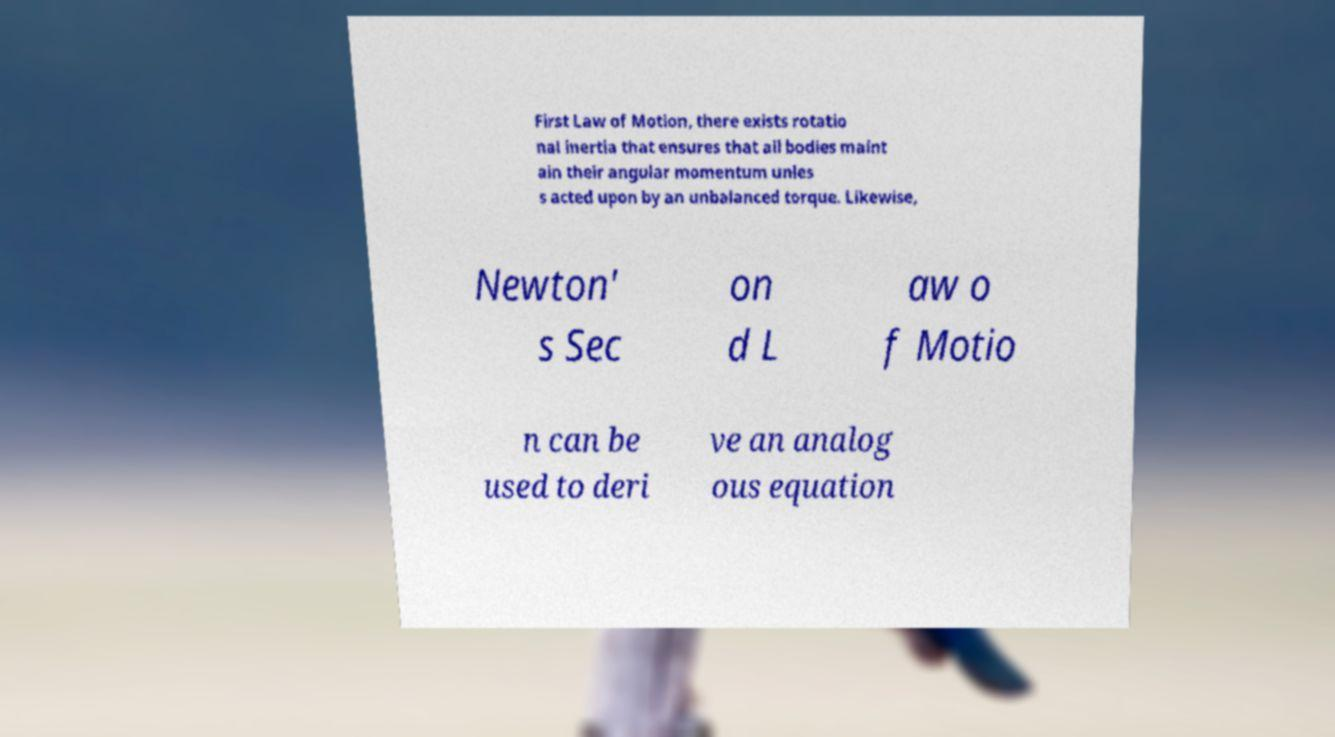For documentation purposes, I need the text within this image transcribed. Could you provide that? First Law of Motion, there exists rotatio nal inertia that ensures that all bodies maint ain their angular momentum unles s acted upon by an unbalanced torque. Likewise, Newton' s Sec on d L aw o f Motio n can be used to deri ve an analog ous equation 